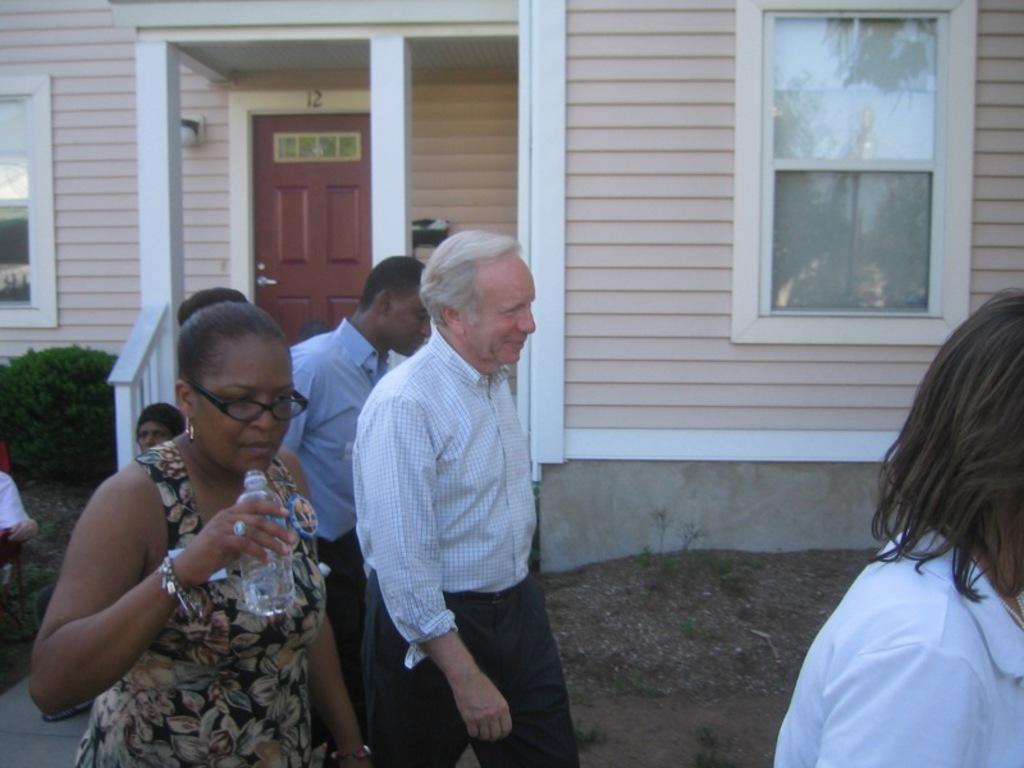Can you describe this image briefly? In this image in the middle, there is a man, he wears a shirt, trouser, he is walking, behind him there is a man, he wears a shirt, trouser. On the left there is a woman, she wears a dress, she is holding a bottle. On the right there is a person. In the background there are some people, plants, house, windows, glass, door and wall. 